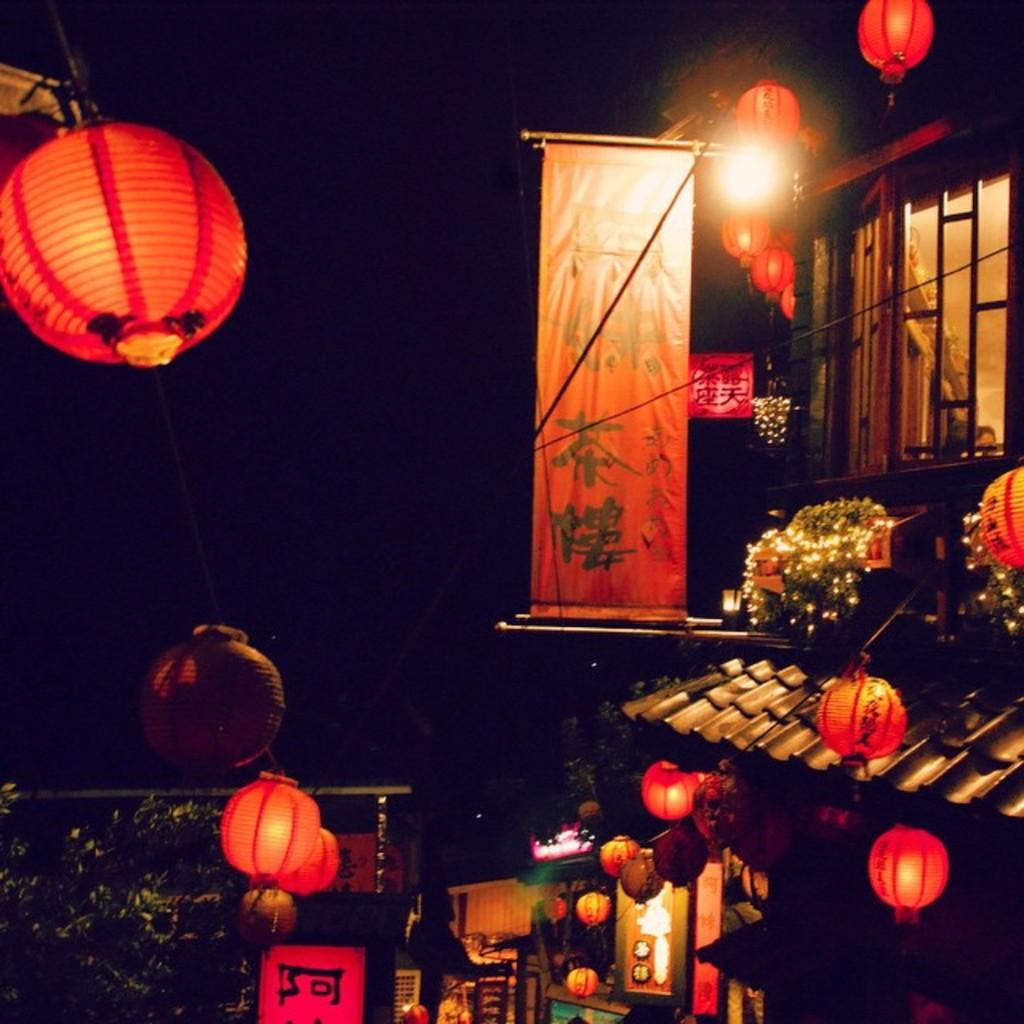What type of lighting is present in the image? There are lanterns in the image. What type of structure can be seen in the image? There is a building in the image. What message or information is conveyed by the banner in the image? There is a banner with text in the image. What type of vegetation is present in the image? There are plants in the image. How would you describe the lighting conditions in the image? The background of the image is dark. Can you hear the song being sung by the rail in the image? There is no rail or singing in the image; it features lanterns, a building, a banner with text, plants, and a dark background. Is the quicksand visible in the image? There is no quicksand present in the image. 